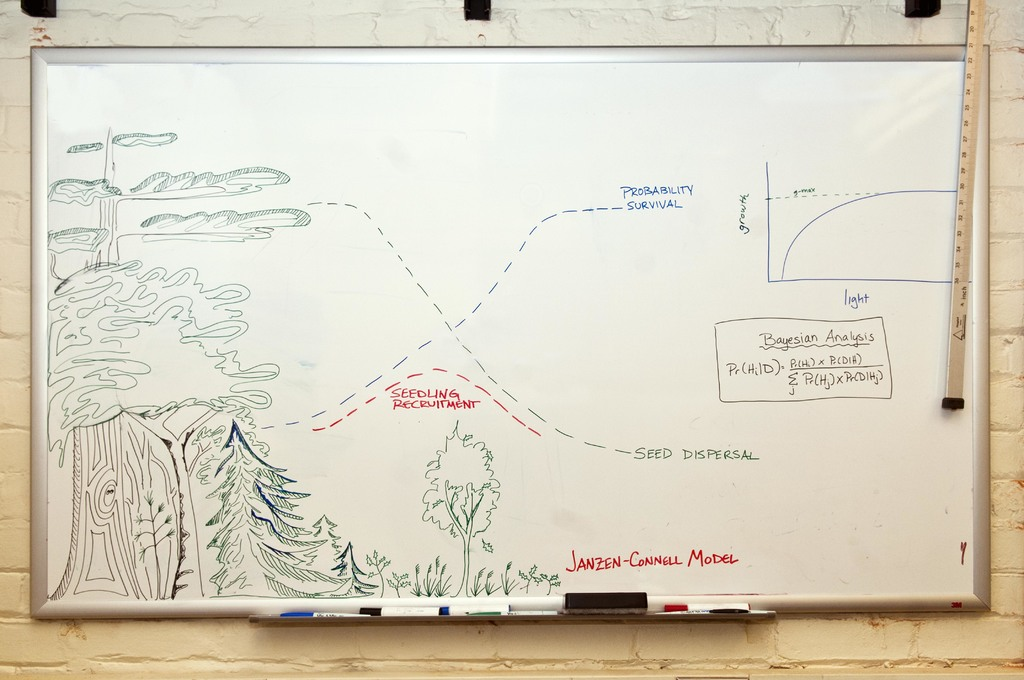What's happening in the scene? The image captures a whiteboard that serves as a canvas for explaining the Janzen-Connell model, a significant hypothesis in the field of ecology. The model is illustrated through a diagram and accompanying text, which together convey the impact of seed dispersal on the survival and recruitment of seedlings. 

The diagram depicts a tree, symbolizing the source of the seeds, and illustrates how these seeds disperse away from it. This visual representation is a key component of the Janzen-Connell model, emphasizing the role of distance in seed survival and the subsequent growth of new plants.

The text on the whiteboard further elaborates on these concepts, mentioning terms such as 'probability', 'survival', 'seedling recruitment', and 'seed dispersal'. These terms are fundamental to understanding the Janzen-Connell model and its implications for plant species survival.

In addition to the general explanation of the model, the text also refers to specific examples of plant species, namely the Pagoda-Baobab and the Banyan-Moringa. These examples provide a real-world context to the theoretical model, making the explanation more relatable and comprehensive.

Overall, the image presents a detailed and informative explanation of the Janzen-Connell model, using both visual and textual elements to convey the complex ecological concepts involved in seed dispersal and plant survival. 